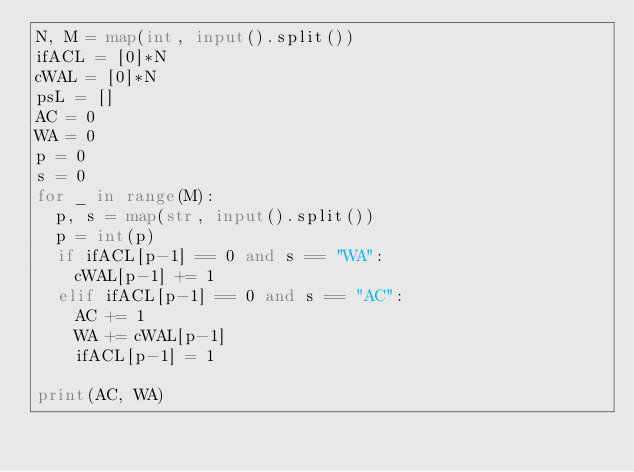<code> <loc_0><loc_0><loc_500><loc_500><_Python_>N, M = map(int, input().split())
ifACL = [0]*N
cWAL = [0]*N
psL = []
AC = 0
WA = 0
p = 0
s = 0
for _ in range(M):
  p, s = map(str, input().split())
  p = int(p)
  if ifACL[p-1] == 0 and s == "WA":
    cWAL[p-1] += 1
  elif ifACL[p-1] == 0 and s == "AC":
    AC += 1
    WA += cWAL[p-1]
    ifACL[p-1] = 1

print(AC, WA)
</code> 